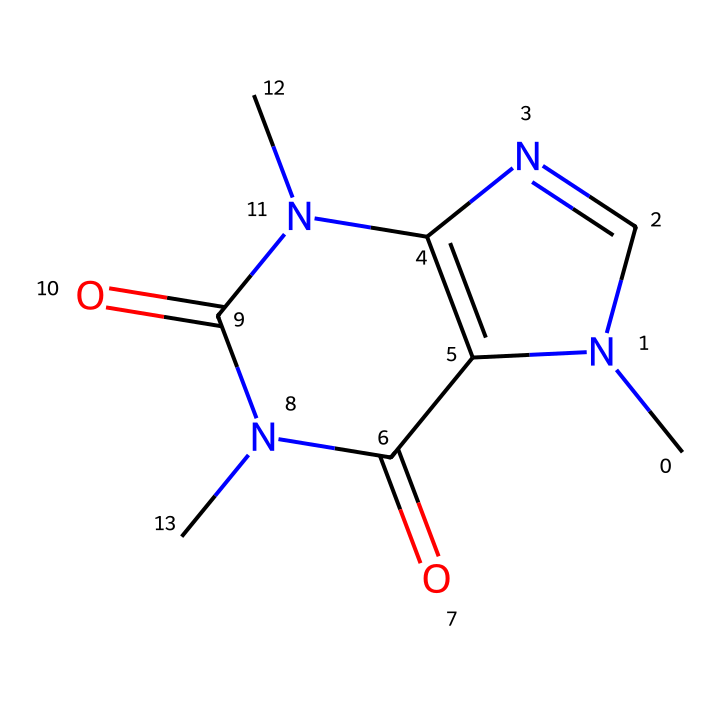How many nitrogen atoms are present in the structure? By analyzing the SMILES representation, we can identify that there are two nitrogen atoms represented by the 'N' notation.
Answer: two What type of ring structure is present in this chemical? The nitrogen and carbon atoms in the chemical structure form heterocycles, which indicates the presence of a ring with different types of atoms.
Answer: heterocyclic What functional groups are present in this chemical? Observing the SMILES, we can identify two carbonyl groups (C=O) and two amine groups (N), which denote the presence of amides and aromatic characteristics.
Answer: amides, aromatic How many total carbon atoms are in the caffeine structure? By counting the 'C's in the SMILES representation, we find that there are eight carbon atoms present in the structure.
Answer: eight What type of bonding is predominant in this aromatic compound? The presence of alternating single and double bonds in the ring structure indicates resonance, which is typical for aromatic compounds.
Answer: resonance Is this compound classified as a stimulant? Caffeine is widely recognized for its stimulating effects on the central nervous system, making it a common stimulant found in energy drinks.
Answer: yes 